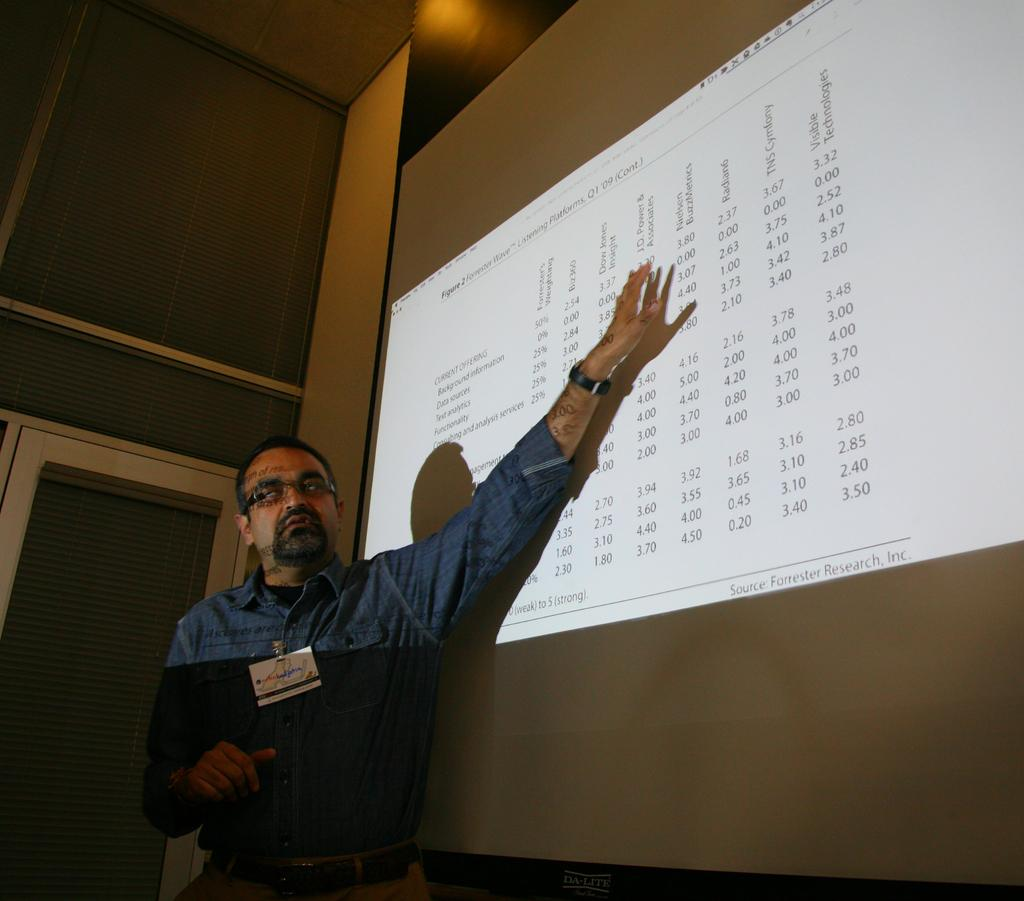What can be seen in the image? There is a person in the image. What is the person wearing? The person is wearing a shirt, a badge, a watch, and spectacles. What is the person doing in the image? The person is standing and showing a screen. What is visible in the background of the image? There is a wall in the background of the image. What type of key is the person holding in the image? There is no key visible in the image; the person is showing a screen. What color are the jeans the person is wearing in the image? The person is not wearing jeans in the image; they are wearing a shirt and other accessories. 